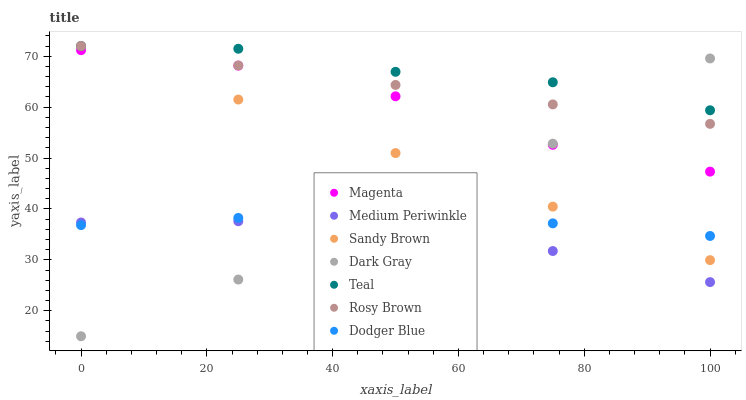Does Medium Periwinkle have the minimum area under the curve?
Answer yes or no. Yes. Does Teal have the maximum area under the curve?
Answer yes or no. Yes. Does Dark Gray have the minimum area under the curve?
Answer yes or no. No. Does Dark Gray have the maximum area under the curve?
Answer yes or no. No. Is Sandy Brown the smoothest?
Answer yes or no. Yes. Is Magenta the roughest?
Answer yes or no. Yes. Is Medium Periwinkle the smoothest?
Answer yes or no. No. Is Medium Periwinkle the roughest?
Answer yes or no. No. Does Dark Gray have the lowest value?
Answer yes or no. Yes. Does Medium Periwinkle have the lowest value?
Answer yes or no. No. Does Sandy Brown have the highest value?
Answer yes or no. Yes. Does Dark Gray have the highest value?
Answer yes or no. No. Is Magenta less than Teal?
Answer yes or no. Yes. Is Magenta greater than Medium Periwinkle?
Answer yes or no. Yes. Does Sandy Brown intersect Magenta?
Answer yes or no. Yes. Is Sandy Brown less than Magenta?
Answer yes or no. No. Is Sandy Brown greater than Magenta?
Answer yes or no. No. Does Magenta intersect Teal?
Answer yes or no. No. 